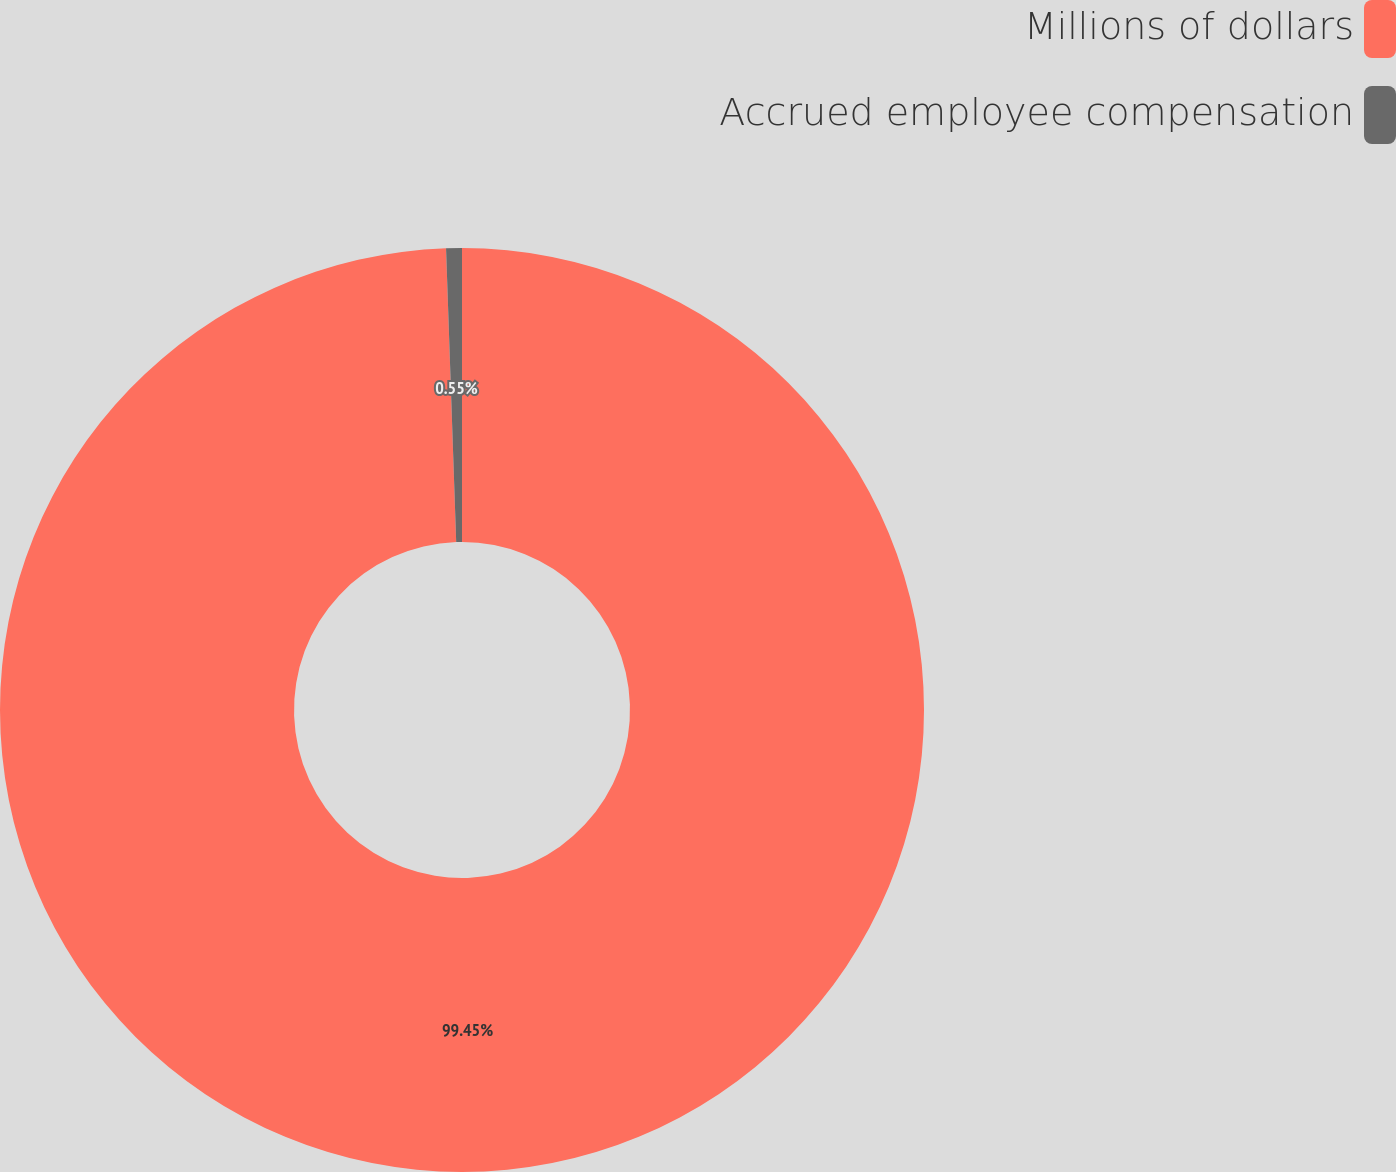Convert chart. <chart><loc_0><loc_0><loc_500><loc_500><pie_chart><fcel>Millions of dollars<fcel>Accrued employee compensation<nl><fcel>99.45%<fcel>0.55%<nl></chart> 